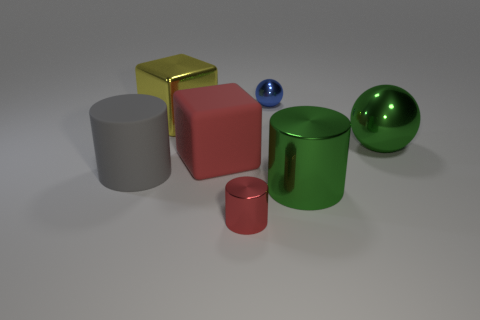Is there a yellow object of the same shape as the big red matte object?
Ensure brevity in your answer.  Yes. How many things are either large gray rubber objects in front of the blue shiny thing or small blue things?
Offer a terse response. 2. Are there more metallic spheres on the right side of the blue ball than tiny red metallic objects in front of the red metallic cylinder?
Your answer should be very brief. Yes. What number of shiny objects are big green objects or gray objects?
Your answer should be very brief. 2. There is a large object that is the same color as the tiny cylinder; what material is it?
Provide a short and direct response. Rubber. Are there fewer large gray cylinders that are on the right side of the red cube than green cylinders behind the tiny blue shiny thing?
Offer a terse response. No. What number of things are large red matte things or large cubes that are in front of the big ball?
Ensure brevity in your answer.  1. What is the material of the sphere that is the same size as the red shiny object?
Offer a terse response. Metal. Is the green ball made of the same material as the big gray object?
Give a very brief answer. No. The cylinder that is to the left of the big green shiny cylinder and on the right side of the big gray rubber thing is what color?
Offer a terse response. Red. 